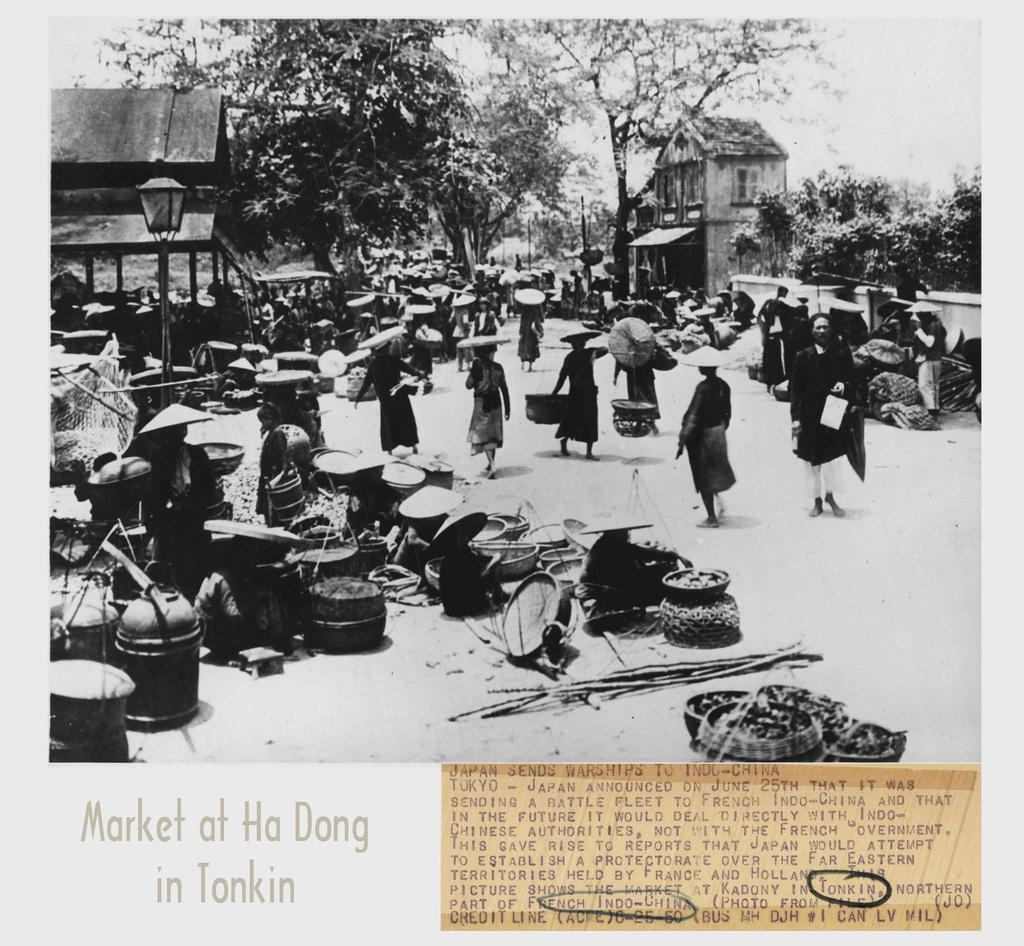<image>
Offer a succinct explanation of the picture presented. a black and white image of people and pots at the market at Ha Dong in Tonkin 